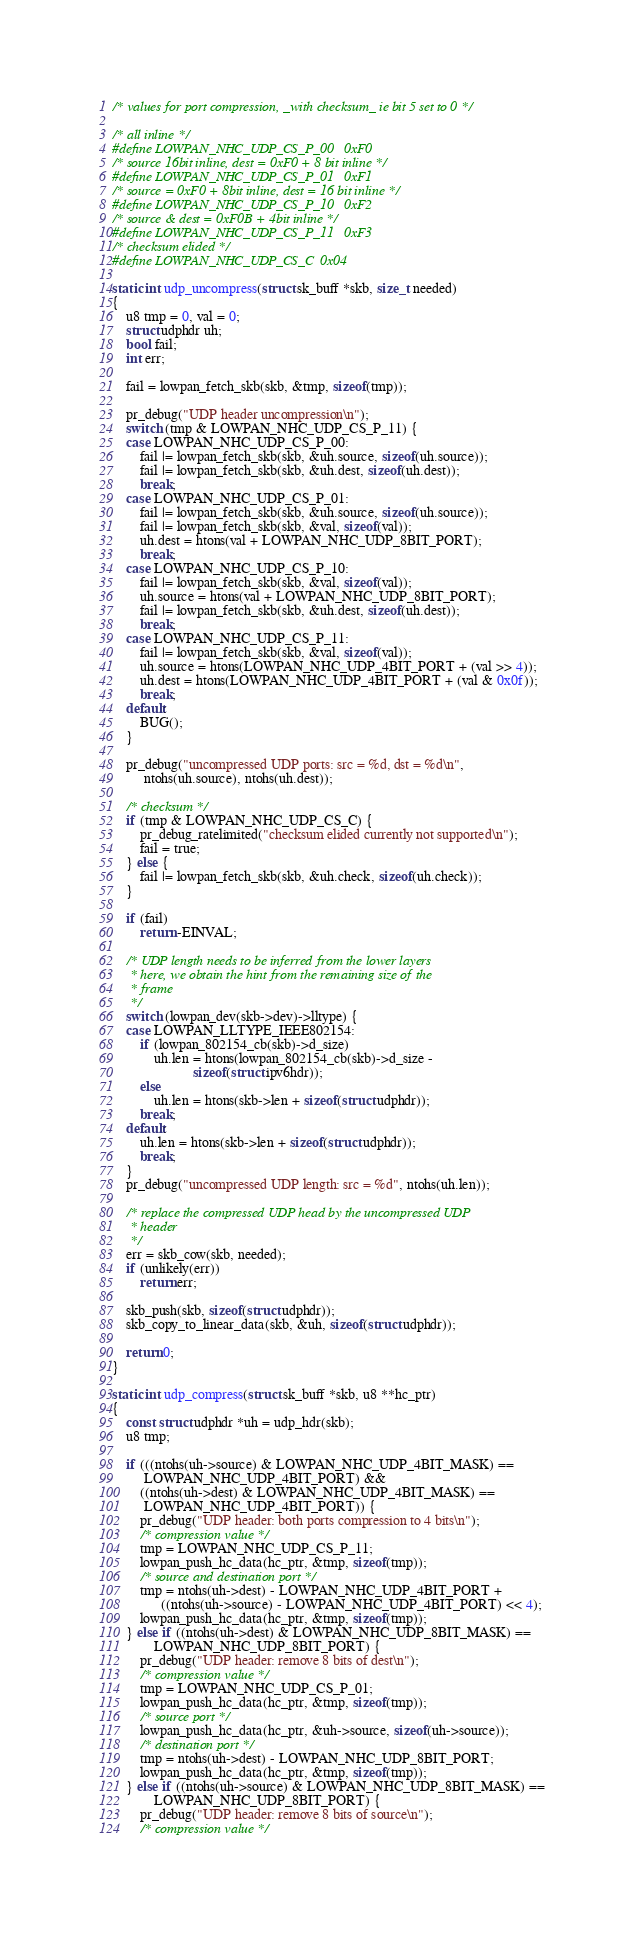<code> <loc_0><loc_0><loc_500><loc_500><_C_>
/* values for port compression, _with checksum_ ie bit 5 set to 0 */

/* all inline */
#define LOWPAN_NHC_UDP_CS_P_00	0xF0
/* source 16bit inline, dest = 0xF0 + 8 bit inline */
#define LOWPAN_NHC_UDP_CS_P_01	0xF1
/* source = 0xF0 + 8bit inline, dest = 16 bit inline */
#define LOWPAN_NHC_UDP_CS_P_10	0xF2
/* source & dest = 0xF0B + 4bit inline */
#define LOWPAN_NHC_UDP_CS_P_11	0xF3
/* checksum elided */
#define LOWPAN_NHC_UDP_CS_C	0x04

static int udp_uncompress(struct sk_buff *skb, size_t needed)
{
	u8 tmp = 0, val = 0;
	struct udphdr uh;
	bool fail;
	int err;

	fail = lowpan_fetch_skb(skb, &tmp, sizeof(tmp));

	pr_debug("UDP header uncompression\n");
	switch (tmp & LOWPAN_NHC_UDP_CS_P_11) {
	case LOWPAN_NHC_UDP_CS_P_00:
		fail |= lowpan_fetch_skb(skb, &uh.source, sizeof(uh.source));
		fail |= lowpan_fetch_skb(skb, &uh.dest, sizeof(uh.dest));
		break;
	case LOWPAN_NHC_UDP_CS_P_01:
		fail |= lowpan_fetch_skb(skb, &uh.source, sizeof(uh.source));
		fail |= lowpan_fetch_skb(skb, &val, sizeof(val));
		uh.dest = htons(val + LOWPAN_NHC_UDP_8BIT_PORT);
		break;
	case LOWPAN_NHC_UDP_CS_P_10:
		fail |= lowpan_fetch_skb(skb, &val, sizeof(val));
		uh.source = htons(val + LOWPAN_NHC_UDP_8BIT_PORT);
		fail |= lowpan_fetch_skb(skb, &uh.dest, sizeof(uh.dest));
		break;
	case LOWPAN_NHC_UDP_CS_P_11:
		fail |= lowpan_fetch_skb(skb, &val, sizeof(val));
		uh.source = htons(LOWPAN_NHC_UDP_4BIT_PORT + (val >> 4));
		uh.dest = htons(LOWPAN_NHC_UDP_4BIT_PORT + (val & 0x0f));
		break;
	default:
		BUG();
	}

	pr_debug("uncompressed UDP ports: src = %d, dst = %d\n",
		 ntohs(uh.source), ntohs(uh.dest));

	/* checksum */
	if (tmp & LOWPAN_NHC_UDP_CS_C) {
		pr_debug_ratelimited("checksum elided currently not supported\n");
		fail = true;
	} else {
		fail |= lowpan_fetch_skb(skb, &uh.check, sizeof(uh.check));
	}

	if (fail)
		return -EINVAL;

	/* UDP length needs to be inferred from the lower layers
	 * here, we obtain the hint from the remaining size of the
	 * frame
	 */
	switch (lowpan_dev(skb->dev)->lltype) {
	case LOWPAN_LLTYPE_IEEE802154:
		if (lowpan_802154_cb(skb)->d_size)
			uh.len = htons(lowpan_802154_cb(skb)->d_size -
				       sizeof(struct ipv6hdr));
		else
			uh.len = htons(skb->len + sizeof(struct udphdr));
		break;
	default:
		uh.len = htons(skb->len + sizeof(struct udphdr));
		break;
	}
	pr_debug("uncompressed UDP length: src = %d", ntohs(uh.len));

	/* replace the compressed UDP head by the uncompressed UDP
	 * header
	 */
	err = skb_cow(skb, needed);
	if (unlikely(err))
		return err;

	skb_push(skb, sizeof(struct udphdr));
	skb_copy_to_linear_data(skb, &uh, sizeof(struct udphdr));

	return 0;
}

static int udp_compress(struct sk_buff *skb, u8 **hc_ptr)
{
	const struct udphdr *uh = udp_hdr(skb);
	u8 tmp;

	if (((ntohs(uh->source) & LOWPAN_NHC_UDP_4BIT_MASK) ==
	     LOWPAN_NHC_UDP_4BIT_PORT) &&
	    ((ntohs(uh->dest) & LOWPAN_NHC_UDP_4BIT_MASK) ==
	     LOWPAN_NHC_UDP_4BIT_PORT)) {
		pr_debug("UDP header: both ports compression to 4 bits\n");
		/* compression value */
		tmp = LOWPAN_NHC_UDP_CS_P_11;
		lowpan_push_hc_data(hc_ptr, &tmp, sizeof(tmp));
		/* source and destination port */
		tmp = ntohs(uh->dest) - LOWPAN_NHC_UDP_4BIT_PORT +
		      ((ntohs(uh->source) - LOWPAN_NHC_UDP_4BIT_PORT) << 4);
		lowpan_push_hc_data(hc_ptr, &tmp, sizeof(tmp));
	} else if ((ntohs(uh->dest) & LOWPAN_NHC_UDP_8BIT_MASK) ==
			LOWPAN_NHC_UDP_8BIT_PORT) {
		pr_debug("UDP header: remove 8 bits of dest\n");
		/* compression value */
		tmp = LOWPAN_NHC_UDP_CS_P_01;
		lowpan_push_hc_data(hc_ptr, &tmp, sizeof(tmp));
		/* source port */
		lowpan_push_hc_data(hc_ptr, &uh->source, sizeof(uh->source));
		/* destination port */
		tmp = ntohs(uh->dest) - LOWPAN_NHC_UDP_8BIT_PORT;
		lowpan_push_hc_data(hc_ptr, &tmp, sizeof(tmp));
	} else if ((ntohs(uh->source) & LOWPAN_NHC_UDP_8BIT_MASK) ==
			LOWPAN_NHC_UDP_8BIT_PORT) {
		pr_debug("UDP header: remove 8 bits of source\n");
		/* compression value */</code> 